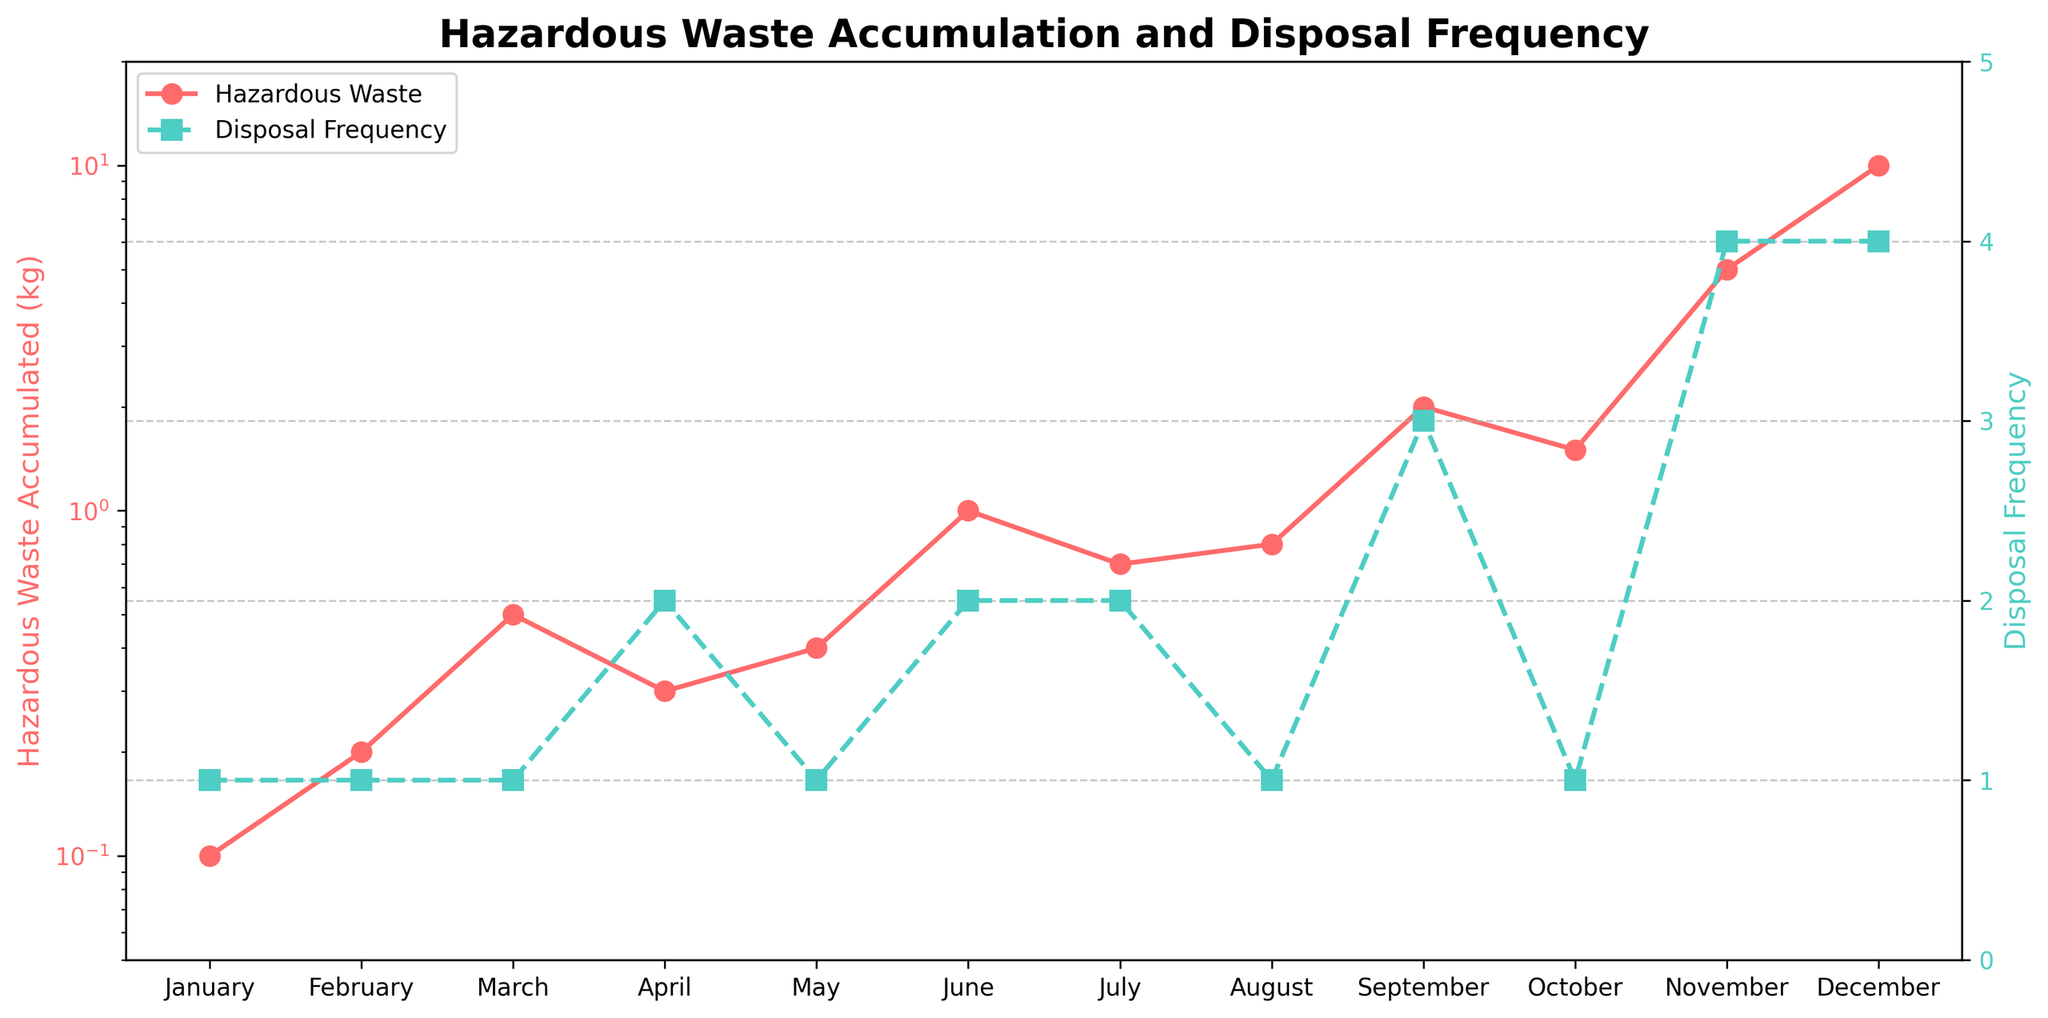What's the title of the figure? The title of the figure is displayed at the top in bold. It summarizes the content of the plot so viewers immediately know the subject matter being presented.
Answer: Hazardous Waste Accumulation and Disposal Frequency What are the labels for the y-axes? The y-axes labels are shown vertically along the axes. The left y-axis (associated with the red line) shows "Hazardous Waste Accumulated (kg)" and the right y-axis (associated with the green dashed line) shows "Disposal Frequency."
Answer: Hazardous Waste Accumulated (kg) and Disposal Frequency In which month did the hazardous waste accumulation first exceed 1 kg? By looking at the red line on the y-axis with log scale, the month when the value crosses the 1 kg mark is identified.
Answer: June By how much did the hazardous waste accumulated change from September to October? Look at the y-values for September and October on the red line: 2.0 kg in September and 1.5 kg in October. Subtract 1.5 kg from 2.0 kg to find the difference.
Answer: 0.5 kg decrease Which month had the highest disposal frequency and what was it? Locate the highest point on the green dashed line and identify the corresponding month and y-value on the right y-axis.
Answer: November, 4 times Between which two consecutive months was the largest increase in hazardous waste accumulation observed? Compare the changes in waste accumulation between each consecutive month by examining the steepness of the red line. The largest increase occurs between November and December where the line has the steepest slope.
Answer: November to December What's the median value of the hazardous waste accumulated over the year? List the waste accumulation values: 0.1, 0.2, 0.3, 0.4, 0.5, 0.7, 0.8, 1.0, 1.5, 2.0, 5.0, 10.0 and find the middle values. Since there are 12 values (even), the median is the average of the 6th and 7th values (i.e., 0.7 and 0.8).
Answer: 0.75 kg How does the accumulation trend change after September? Observe the red line segment post-September. Note that it rises steeply after September with significant increases in both November and December.
Answer: Increases significantly In which months did the disposal frequency reach its minimum and what was the frequency? Find the lowest points on the green dashed line and identify the corresponding months and frequency value.
Answer: January, February, March, May, August, October; 1 time 